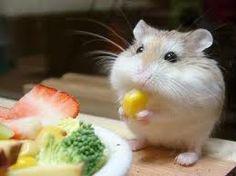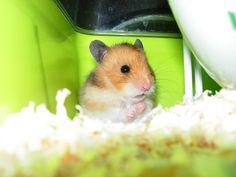The first image is the image on the left, the second image is the image on the right. Considering the images on both sides, is "In one image, a hamster is holding a bit of corn in its hands." valid? Answer yes or no. Yes. The first image is the image on the left, the second image is the image on the right. Assess this claim about the two images: "One hamster is eating a single kernel of corn.". Correct or not? Answer yes or no. Yes. 